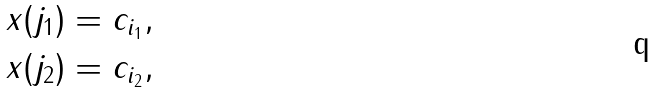<formula> <loc_0><loc_0><loc_500><loc_500>& x ( j _ { 1 } ) = c _ { i _ { 1 } } , \\ & x ( j _ { 2 } ) = c _ { i _ { 2 } } ,</formula> 